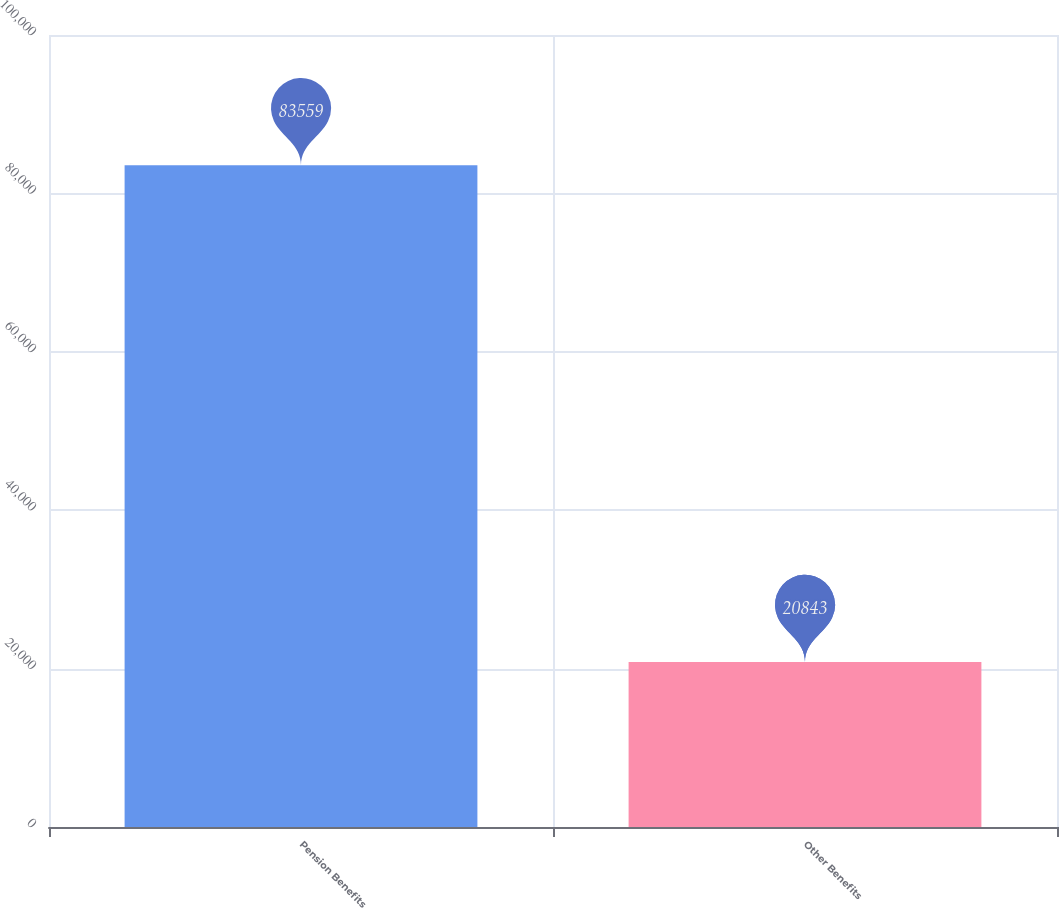Convert chart. <chart><loc_0><loc_0><loc_500><loc_500><bar_chart><fcel>Pension Benefits<fcel>Other Benefits<nl><fcel>83559<fcel>20843<nl></chart> 